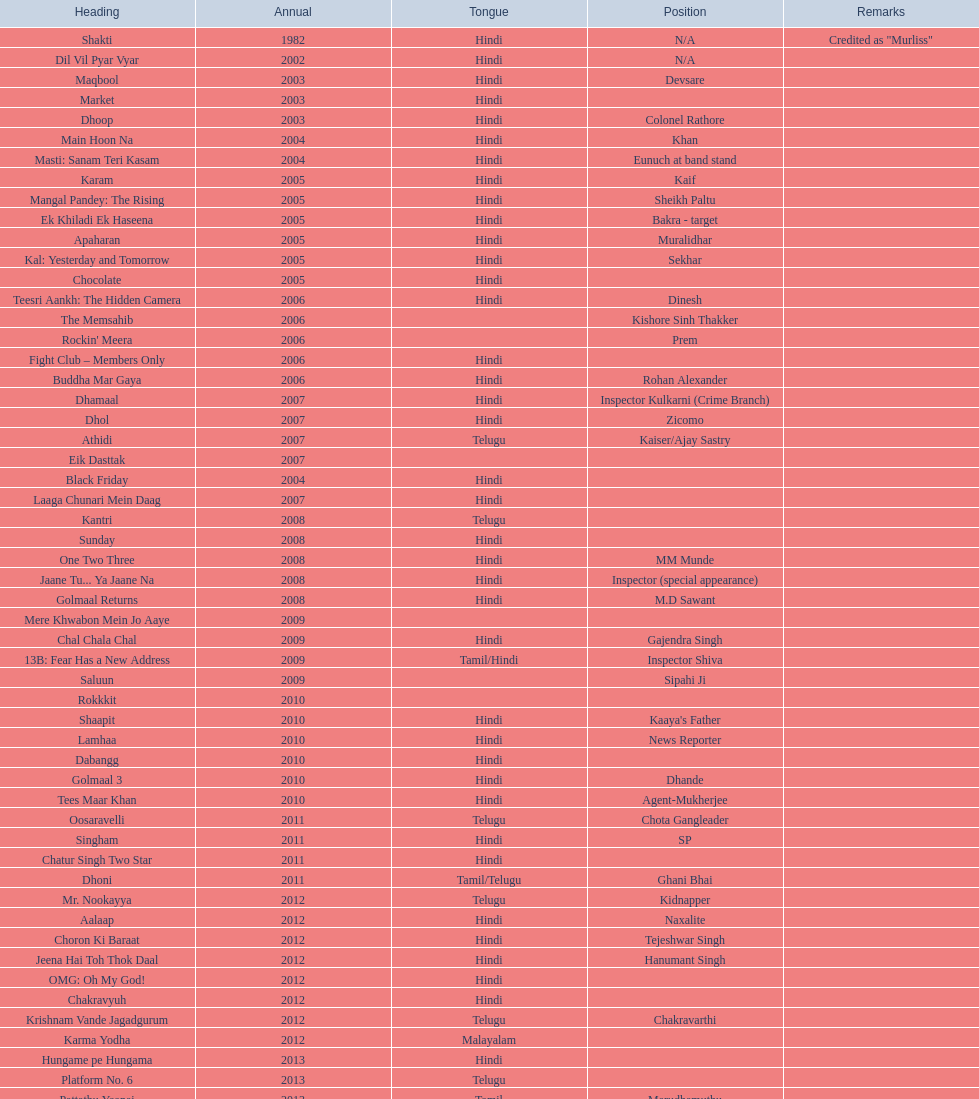How many roles has this actor had? 36. 